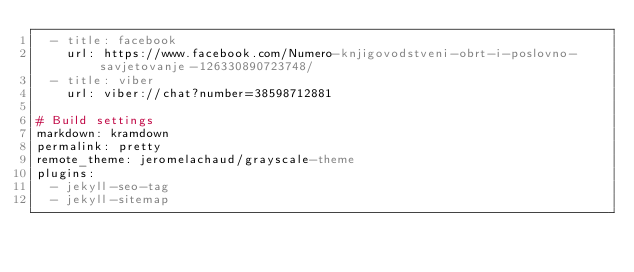Convert code to text. <code><loc_0><loc_0><loc_500><loc_500><_YAML_>  - title: facebook
    url: https://www.facebook.com/Numero-knjigovodstveni-obrt-i-poslovno-savjetovanje-126330890723748/
  - title: viber
    url: viber://chat?number=38598712881

# Build settings
markdown: kramdown
permalink: pretty
remote_theme: jeromelachaud/grayscale-theme
plugins:
  - jekyll-seo-tag
  - jekyll-sitemap
</code> 